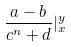<formula> <loc_0><loc_0><loc_500><loc_500>\frac { a - b } { c ^ { n } + d } | _ { x } ^ { y }</formula> 